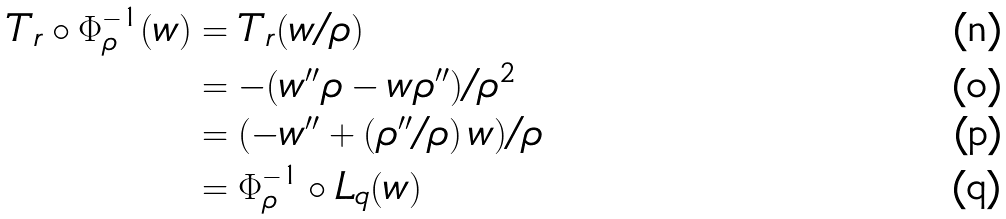<formula> <loc_0><loc_0><loc_500><loc_500>T _ { r } \circ \Phi _ { \rho } ^ { - 1 } ( w ) & = T _ { r } ( w / \rho ) \\ & = - ( w ^ { \prime \prime } \rho - w \rho ^ { \prime \prime } ) / \rho ^ { 2 } \\ & = ( - w ^ { \prime \prime } + ( \rho ^ { \prime \prime } / \rho ) \, w ) / \rho \\ & = \Phi _ { \rho } ^ { - 1 } \circ L _ { q } ( w )</formula> 